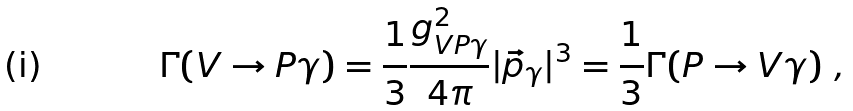<formula> <loc_0><loc_0><loc_500><loc_500>\Gamma ( V \rightarrow P \gamma ) = \frac { 1 } { 3 } \frac { g ^ { 2 } _ { V P \gamma } } { 4 \pi } | \vec { p } _ { \gamma } | ^ { 3 } = \frac { 1 } { 3 } \Gamma ( P \rightarrow V \gamma ) \ ,</formula> 